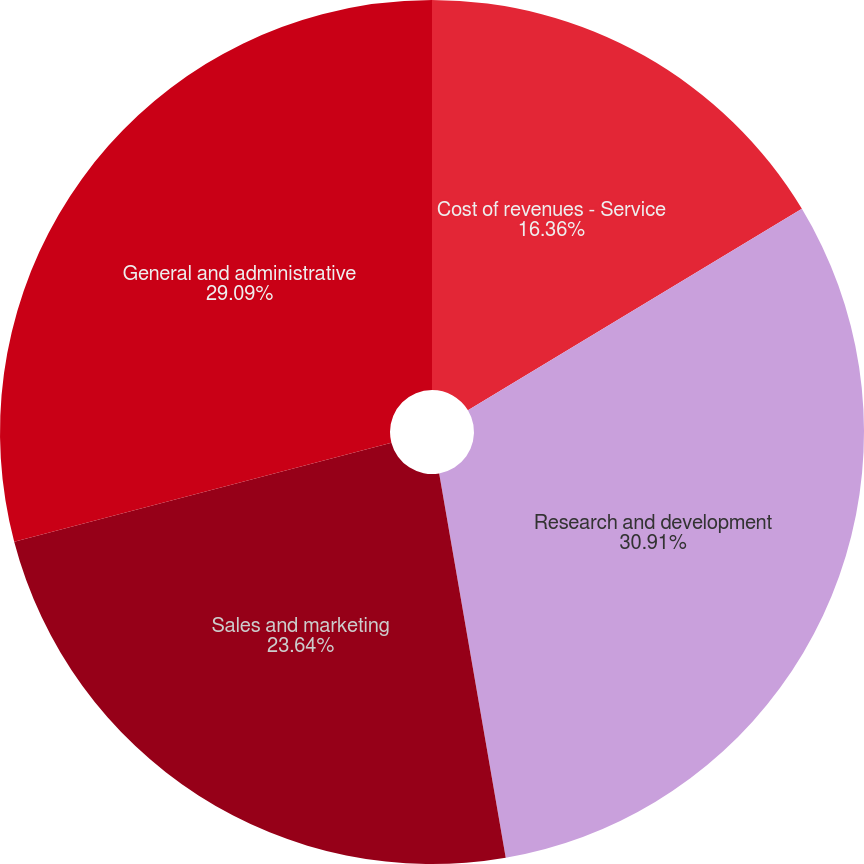Convert chart. <chart><loc_0><loc_0><loc_500><loc_500><pie_chart><fcel>Cost of revenues - Service<fcel>Research and development<fcel>Sales and marketing<fcel>General and administrative<nl><fcel>16.36%<fcel>30.91%<fcel>23.64%<fcel>29.09%<nl></chart> 